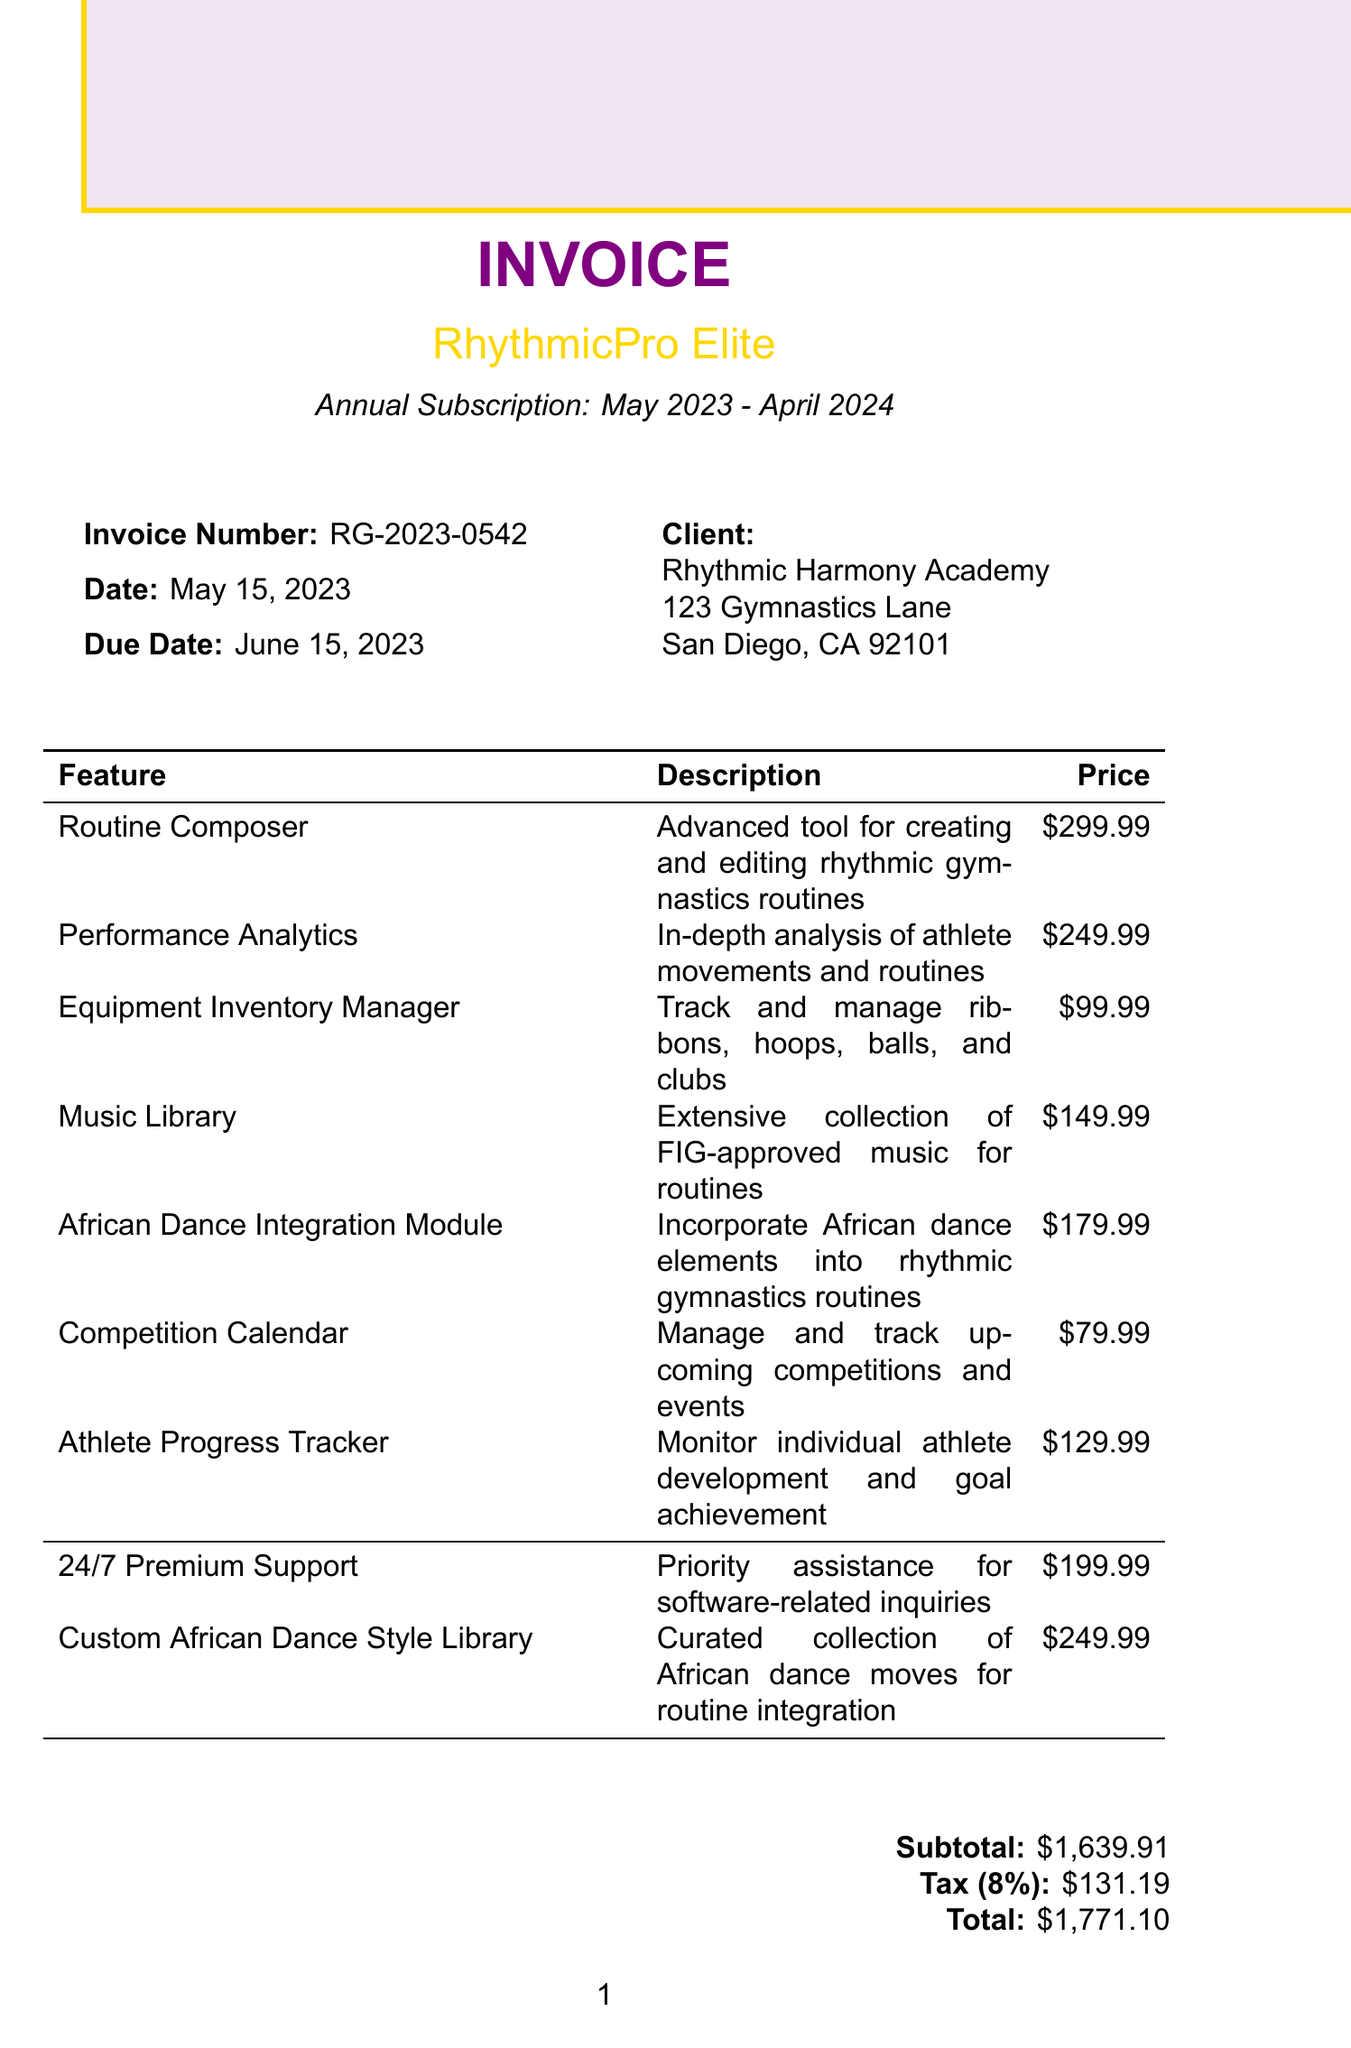What is the invoice number? The invoice number is stated in the document as RG-2023-0542.
Answer: RG-2023-0542 What is the total amount due? The total amount due is the sum of the subtotal and tax, which is $1771.10.
Answer: $1771.10 What subscription period is listed? The subscription period is mentioned as Annual (May 2023 - April 2024).
Answer: Annual (May 2023 - April 2024) What feature has the highest price? The feature with the highest price listed in the document is the "Custom African Dance Style Library."
Answer: Custom African Dance Style Library How much is the tax rate? The tax rate specified in the document is 8%.
Answer: 8% What is one of the payment methods available? The document lists several payment methods; for instance, "Credit Card" is one of them.
Answer: Credit Card When is the payment due? According to the terms, payment is due within 30 days of the invoice date, which is June 15, 2023.
Answer: June 15, 2023 What additional service costs $199.99? The additional service that costs $199.99 is "24/7 Premium Support."
Answer: 24/7 Premium Support What is the subtotal amount? The subtotal amount is provided in the payment details section as $1,639.91.
Answer: $1,639.91 